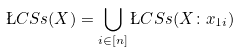<formula> <loc_0><loc_0><loc_500><loc_500>\L C S s ( X ) = \bigcup _ { i \in [ n ] } \L C S s ( X \colon x _ { 1 i } )</formula> 